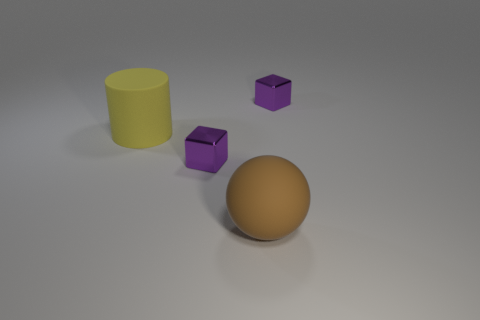What might be the purpose of arranging these objects like this? This arrangement of objects might be intended for educational purposes, to demonstrate the concept of geometric shapes and their properties, such as volume and surface area, in a visual and easy-to-understand manner. 